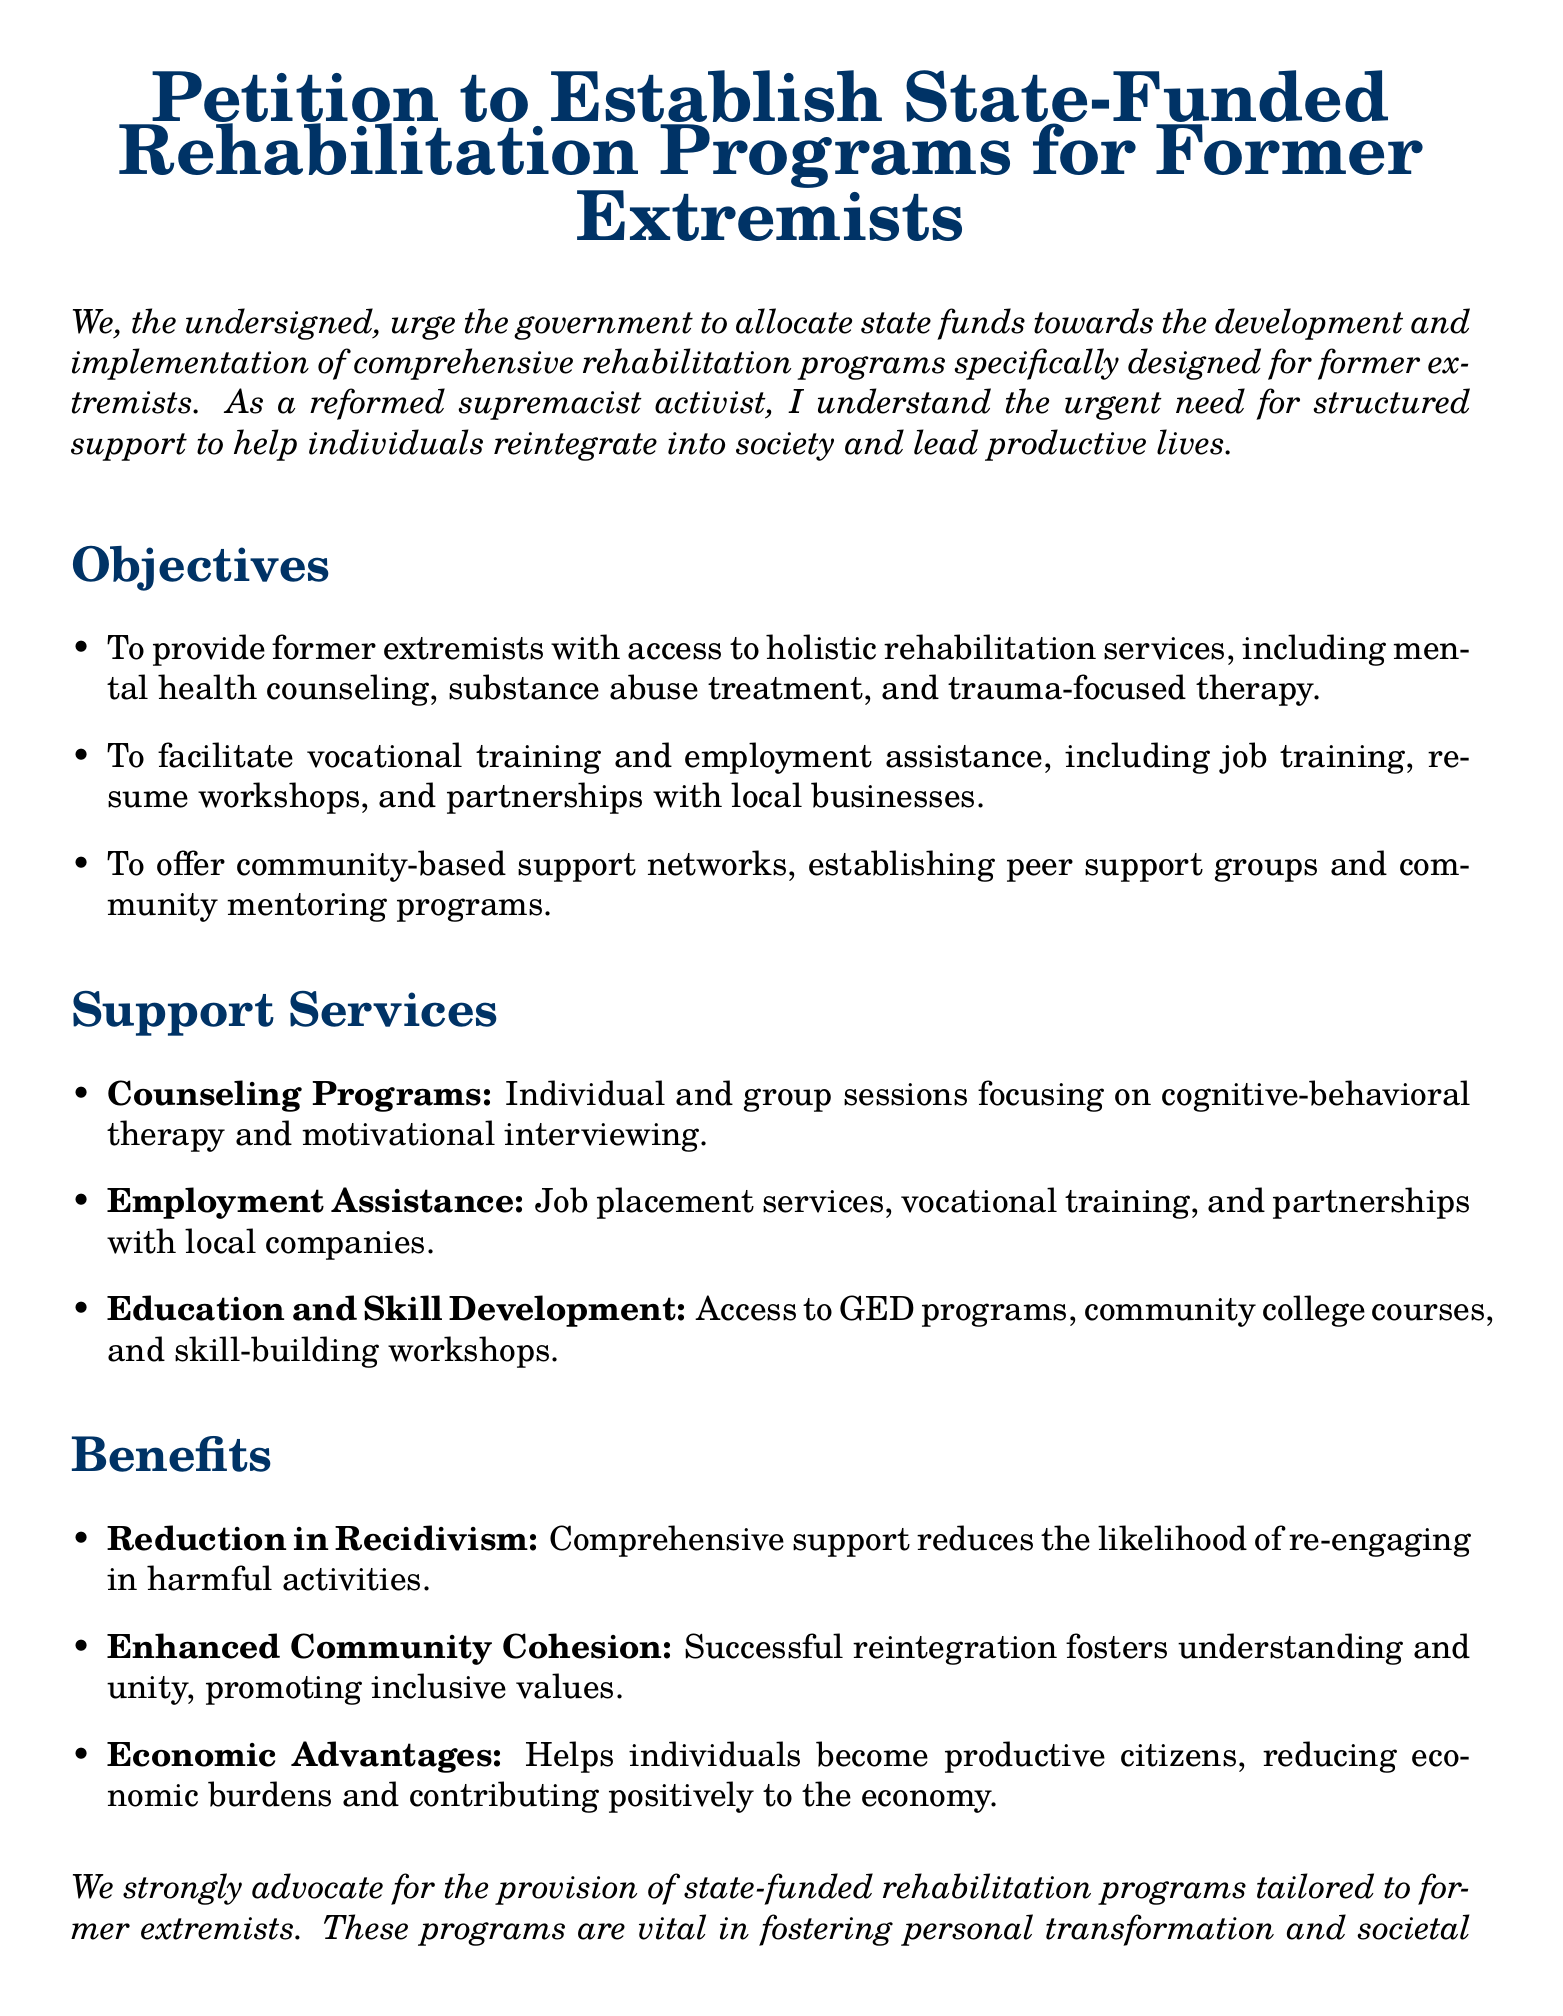What is the title of the petition? The title of the petition is explicitly stated at the top of the document.
Answer: Petition to Establish State-Funded Rehabilitation Programs for Former Extremists How many objectives are listed in the document? The document provides a specific number of objectives under the "Objectives" section.
Answer: Three What type of therapy is mentioned in the counseling programs? The document specifies a type of therapy that is included in the counseling programs.
Answer: Cognitive-behavioral therapy What is one of the economic advantages stated in the document? The document outlines benefits, including economic aspects.
Answer: Reducing economic burdens What kind of programs does the document advocate for? The document describes a specific type of support program aimed at a certain group.
Answer: State-funded rehabilitation programs What service is offered through community-based support networks? The document identifies specific services within community support networks.
Answer: Peer support groups How does the document propose to help with job placements? The document states a method included in employment assistance services related to job placements.
Answer: Job placement services What is the target group of the rehabilitation programs? The document explicitly defines the group that these rehabilitation programs are aimed at.
Answer: Former extremists 